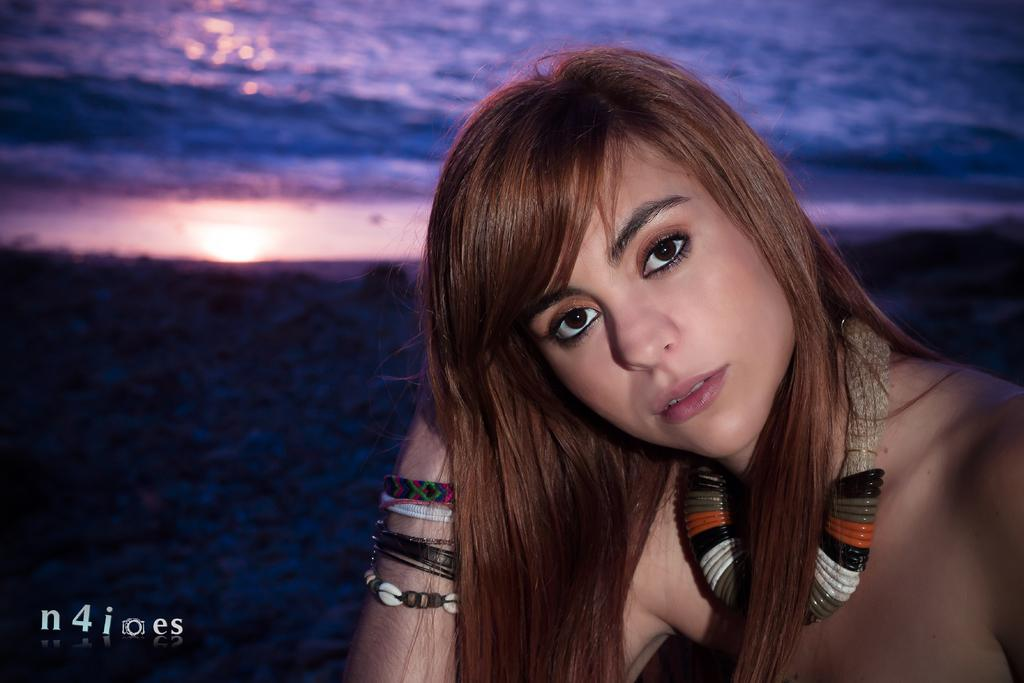Who is the main subject in the picture? There is a woman in the picture. What is the woman wearing in the picture? The woman is wearing an ornament. What can be seen in the background of the picture? There is water visible in the background of the picture. Where is the text located in the picture? The text is at the bottom left corner of the picture. What type of plastic is the mom holding in the picture? There is no mom or plastic object present in the image. How many bits of information can be found in the text at the bottom left corner of the picture? The number of bits of information in the text cannot be determined from the image alone. 